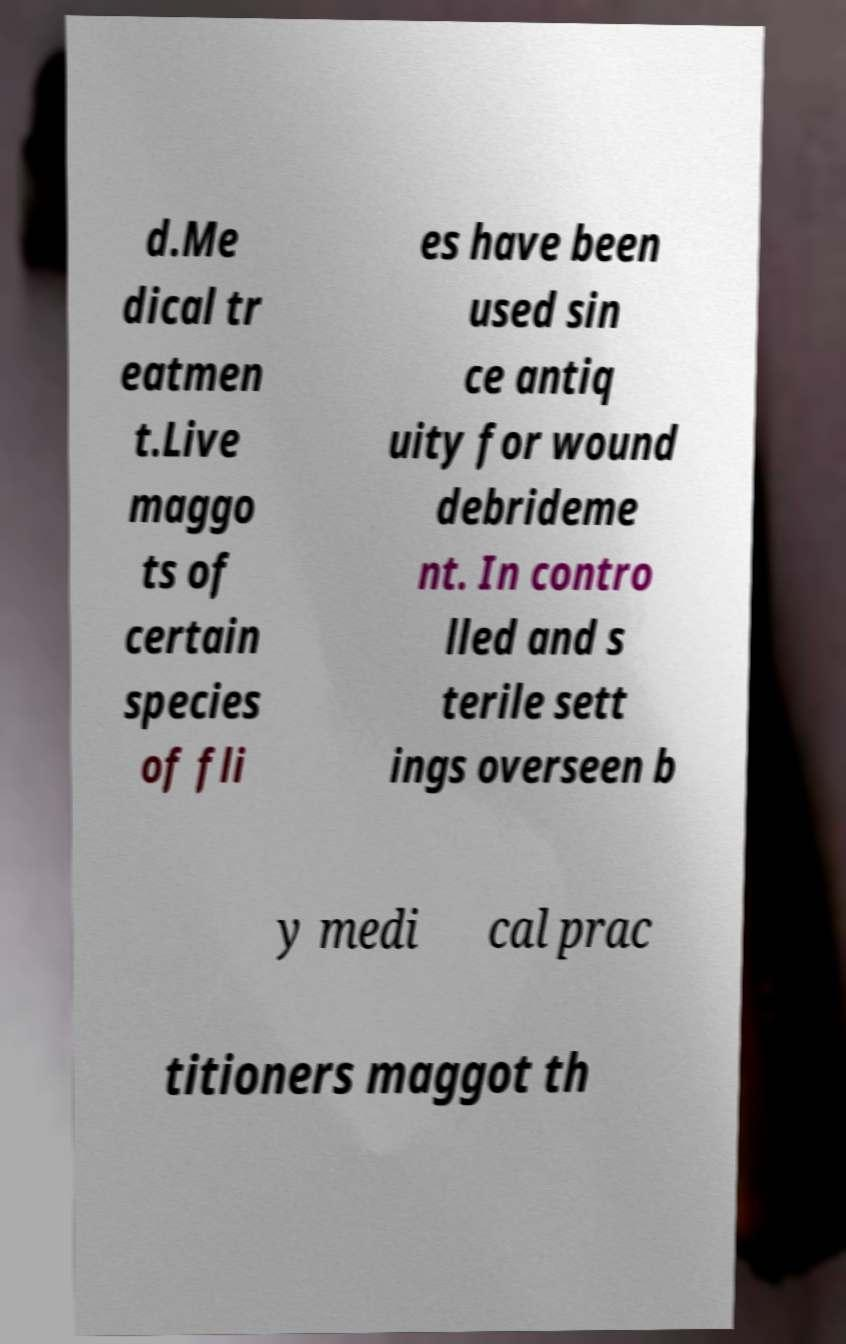Can you read and provide the text displayed in the image?This photo seems to have some interesting text. Can you extract and type it out for me? d.Me dical tr eatmen t.Live maggo ts of certain species of fli es have been used sin ce antiq uity for wound debrideme nt. In contro lled and s terile sett ings overseen b y medi cal prac titioners maggot th 